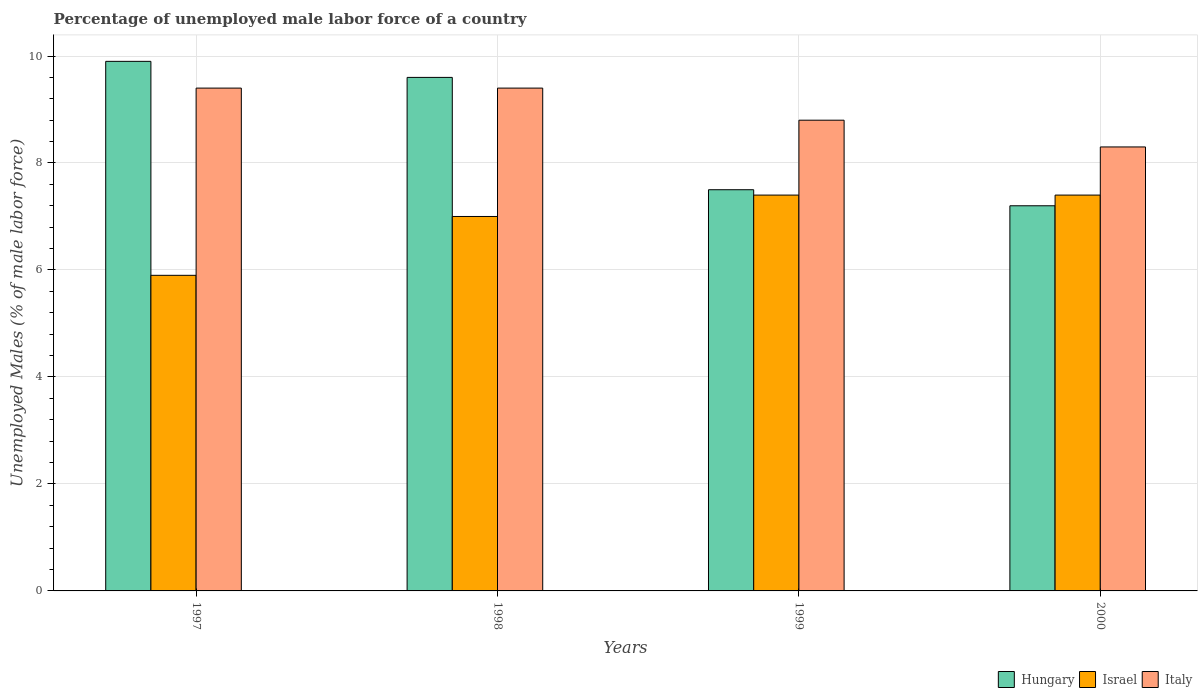Are the number of bars on each tick of the X-axis equal?
Your response must be concise. Yes. How many bars are there on the 3rd tick from the left?
Offer a terse response. 3. How many bars are there on the 3rd tick from the right?
Your answer should be very brief. 3. What is the label of the 3rd group of bars from the left?
Make the answer very short. 1999. What is the percentage of unemployed male labor force in Israel in 1998?
Your response must be concise. 7. Across all years, what is the maximum percentage of unemployed male labor force in Hungary?
Offer a terse response. 9.9. Across all years, what is the minimum percentage of unemployed male labor force in Israel?
Your answer should be compact. 5.9. What is the total percentage of unemployed male labor force in Italy in the graph?
Provide a succinct answer. 35.9. What is the difference between the percentage of unemployed male labor force in Italy in 1997 and that in 2000?
Provide a succinct answer. 1.1. What is the difference between the percentage of unemployed male labor force in Israel in 2000 and the percentage of unemployed male labor force in Italy in 1998?
Offer a very short reply. -2. What is the average percentage of unemployed male labor force in Israel per year?
Your response must be concise. 6.93. In the year 1998, what is the difference between the percentage of unemployed male labor force in Italy and percentage of unemployed male labor force in Israel?
Your answer should be compact. 2.4. What is the ratio of the percentage of unemployed male labor force in Israel in 1997 to that in 1998?
Offer a terse response. 0.84. Is the percentage of unemployed male labor force in Italy in 1998 less than that in 2000?
Keep it short and to the point. No. What is the difference between the highest and the second highest percentage of unemployed male labor force in Hungary?
Provide a short and direct response. 0.3. In how many years, is the percentage of unemployed male labor force in Italy greater than the average percentage of unemployed male labor force in Italy taken over all years?
Ensure brevity in your answer.  2. Is the sum of the percentage of unemployed male labor force in Hungary in 1997 and 1999 greater than the maximum percentage of unemployed male labor force in Israel across all years?
Your answer should be compact. Yes. What does the 1st bar from the left in 1997 represents?
Your answer should be compact. Hungary. What does the 3rd bar from the right in 1997 represents?
Make the answer very short. Hungary. How many bars are there?
Your response must be concise. 12. Does the graph contain any zero values?
Give a very brief answer. No. Does the graph contain grids?
Make the answer very short. Yes. How are the legend labels stacked?
Your answer should be very brief. Horizontal. What is the title of the graph?
Your answer should be very brief. Percentage of unemployed male labor force of a country. What is the label or title of the Y-axis?
Keep it short and to the point. Unemployed Males (% of male labor force). What is the Unemployed Males (% of male labor force) in Hungary in 1997?
Offer a very short reply. 9.9. What is the Unemployed Males (% of male labor force) in Israel in 1997?
Make the answer very short. 5.9. What is the Unemployed Males (% of male labor force) in Italy in 1997?
Your answer should be compact. 9.4. What is the Unemployed Males (% of male labor force) in Hungary in 1998?
Offer a very short reply. 9.6. What is the Unemployed Males (% of male labor force) in Israel in 1998?
Provide a succinct answer. 7. What is the Unemployed Males (% of male labor force) of Italy in 1998?
Give a very brief answer. 9.4. What is the Unemployed Males (% of male labor force) in Hungary in 1999?
Your answer should be compact. 7.5. What is the Unemployed Males (% of male labor force) in Israel in 1999?
Your answer should be very brief. 7.4. What is the Unemployed Males (% of male labor force) in Italy in 1999?
Provide a short and direct response. 8.8. What is the Unemployed Males (% of male labor force) in Hungary in 2000?
Give a very brief answer. 7.2. What is the Unemployed Males (% of male labor force) of Israel in 2000?
Give a very brief answer. 7.4. What is the Unemployed Males (% of male labor force) in Italy in 2000?
Provide a succinct answer. 8.3. Across all years, what is the maximum Unemployed Males (% of male labor force) of Hungary?
Your answer should be very brief. 9.9. Across all years, what is the maximum Unemployed Males (% of male labor force) in Israel?
Provide a succinct answer. 7.4. Across all years, what is the maximum Unemployed Males (% of male labor force) in Italy?
Give a very brief answer. 9.4. Across all years, what is the minimum Unemployed Males (% of male labor force) in Hungary?
Provide a short and direct response. 7.2. Across all years, what is the minimum Unemployed Males (% of male labor force) of Israel?
Keep it short and to the point. 5.9. Across all years, what is the minimum Unemployed Males (% of male labor force) of Italy?
Your answer should be compact. 8.3. What is the total Unemployed Males (% of male labor force) in Hungary in the graph?
Offer a very short reply. 34.2. What is the total Unemployed Males (% of male labor force) in Israel in the graph?
Provide a succinct answer. 27.7. What is the total Unemployed Males (% of male labor force) in Italy in the graph?
Keep it short and to the point. 35.9. What is the difference between the Unemployed Males (% of male labor force) in Hungary in 1997 and that in 1998?
Offer a very short reply. 0.3. What is the difference between the Unemployed Males (% of male labor force) in Israel in 1997 and that in 1998?
Make the answer very short. -1.1. What is the difference between the Unemployed Males (% of male labor force) in Israel in 1997 and that in 2000?
Provide a short and direct response. -1.5. What is the difference between the Unemployed Males (% of male labor force) in Italy in 1998 and that in 1999?
Your answer should be compact. 0.6. What is the difference between the Unemployed Males (% of male labor force) in Hungary in 1998 and that in 2000?
Make the answer very short. 2.4. What is the difference between the Unemployed Males (% of male labor force) in Israel in 1998 and that in 2000?
Provide a short and direct response. -0.4. What is the difference between the Unemployed Males (% of male labor force) of Italy in 1998 and that in 2000?
Keep it short and to the point. 1.1. What is the difference between the Unemployed Males (% of male labor force) in Italy in 1999 and that in 2000?
Your answer should be compact. 0.5. What is the difference between the Unemployed Males (% of male labor force) of Hungary in 1997 and the Unemployed Males (% of male labor force) of Israel in 1998?
Make the answer very short. 2.9. What is the difference between the Unemployed Males (% of male labor force) in Israel in 1997 and the Unemployed Males (% of male labor force) in Italy in 1998?
Your answer should be very brief. -3.5. What is the difference between the Unemployed Males (% of male labor force) in Hungary in 1997 and the Unemployed Males (% of male labor force) in Israel in 1999?
Keep it short and to the point. 2.5. What is the difference between the Unemployed Males (% of male labor force) in Hungary in 1997 and the Unemployed Males (% of male labor force) in Italy in 1999?
Keep it short and to the point. 1.1. What is the difference between the Unemployed Males (% of male labor force) in Israel in 1997 and the Unemployed Males (% of male labor force) in Italy in 1999?
Provide a short and direct response. -2.9. What is the difference between the Unemployed Males (% of male labor force) of Israel in 1997 and the Unemployed Males (% of male labor force) of Italy in 2000?
Give a very brief answer. -2.4. What is the difference between the Unemployed Males (% of male labor force) of Hungary in 1998 and the Unemployed Males (% of male labor force) of Italy in 1999?
Your response must be concise. 0.8. What is the difference between the Unemployed Males (% of male labor force) in Hungary in 1998 and the Unemployed Males (% of male labor force) in Israel in 2000?
Provide a succinct answer. 2.2. What is the difference between the Unemployed Males (% of male labor force) in Hungary in 1998 and the Unemployed Males (% of male labor force) in Italy in 2000?
Keep it short and to the point. 1.3. What is the difference between the Unemployed Males (% of male labor force) of Israel in 1998 and the Unemployed Males (% of male labor force) of Italy in 2000?
Make the answer very short. -1.3. What is the difference between the Unemployed Males (% of male labor force) in Israel in 1999 and the Unemployed Males (% of male labor force) in Italy in 2000?
Give a very brief answer. -0.9. What is the average Unemployed Males (% of male labor force) in Hungary per year?
Offer a very short reply. 8.55. What is the average Unemployed Males (% of male labor force) of Israel per year?
Provide a short and direct response. 6.92. What is the average Unemployed Males (% of male labor force) in Italy per year?
Keep it short and to the point. 8.97. In the year 1997, what is the difference between the Unemployed Males (% of male labor force) of Hungary and Unemployed Males (% of male labor force) of Israel?
Your answer should be very brief. 4. In the year 1997, what is the difference between the Unemployed Males (% of male labor force) in Hungary and Unemployed Males (% of male labor force) in Italy?
Offer a very short reply. 0.5. In the year 1998, what is the difference between the Unemployed Males (% of male labor force) of Hungary and Unemployed Males (% of male labor force) of Israel?
Make the answer very short. 2.6. In the year 1999, what is the difference between the Unemployed Males (% of male labor force) of Hungary and Unemployed Males (% of male labor force) of Israel?
Your response must be concise. 0.1. In the year 1999, what is the difference between the Unemployed Males (% of male labor force) of Israel and Unemployed Males (% of male labor force) of Italy?
Your answer should be very brief. -1.4. In the year 2000, what is the difference between the Unemployed Males (% of male labor force) of Hungary and Unemployed Males (% of male labor force) of Israel?
Provide a short and direct response. -0.2. In the year 2000, what is the difference between the Unemployed Males (% of male labor force) in Israel and Unemployed Males (% of male labor force) in Italy?
Provide a succinct answer. -0.9. What is the ratio of the Unemployed Males (% of male labor force) of Hungary in 1997 to that in 1998?
Your answer should be compact. 1.03. What is the ratio of the Unemployed Males (% of male labor force) of Israel in 1997 to that in 1998?
Your response must be concise. 0.84. What is the ratio of the Unemployed Males (% of male labor force) of Hungary in 1997 to that in 1999?
Provide a succinct answer. 1.32. What is the ratio of the Unemployed Males (% of male labor force) in Israel in 1997 to that in 1999?
Give a very brief answer. 0.8. What is the ratio of the Unemployed Males (% of male labor force) of Italy in 1997 to that in 1999?
Offer a very short reply. 1.07. What is the ratio of the Unemployed Males (% of male labor force) of Hungary in 1997 to that in 2000?
Provide a succinct answer. 1.38. What is the ratio of the Unemployed Males (% of male labor force) in Israel in 1997 to that in 2000?
Provide a succinct answer. 0.8. What is the ratio of the Unemployed Males (% of male labor force) in Italy in 1997 to that in 2000?
Keep it short and to the point. 1.13. What is the ratio of the Unemployed Males (% of male labor force) in Hungary in 1998 to that in 1999?
Ensure brevity in your answer.  1.28. What is the ratio of the Unemployed Males (% of male labor force) of Israel in 1998 to that in 1999?
Provide a short and direct response. 0.95. What is the ratio of the Unemployed Males (% of male labor force) in Italy in 1998 to that in 1999?
Your answer should be compact. 1.07. What is the ratio of the Unemployed Males (% of male labor force) in Hungary in 1998 to that in 2000?
Your answer should be very brief. 1.33. What is the ratio of the Unemployed Males (% of male labor force) in Israel in 1998 to that in 2000?
Offer a very short reply. 0.95. What is the ratio of the Unemployed Males (% of male labor force) of Italy in 1998 to that in 2000?
Offer a very short reply. 1.13. What is the ratio of the Unemployed Males (% of male labor force) in Hungary in 1999 to that in 2000?
Your answer should be very brief. 1.04. What is the ratio of the Unemployed Males (% of male labor force) in Israel in 1999 to that in 2000?
Make the answer very short. 1. What is the ratio of the Unemployed Males (% of male labor force) of Italy in 1999 to that in 2000?
Provide a succinct answer. 1.06. What is the difference between the highest and the second highest Unemployed Males (% of male labor force) in Hungary?
Provide a succinct answer. 0.3. 